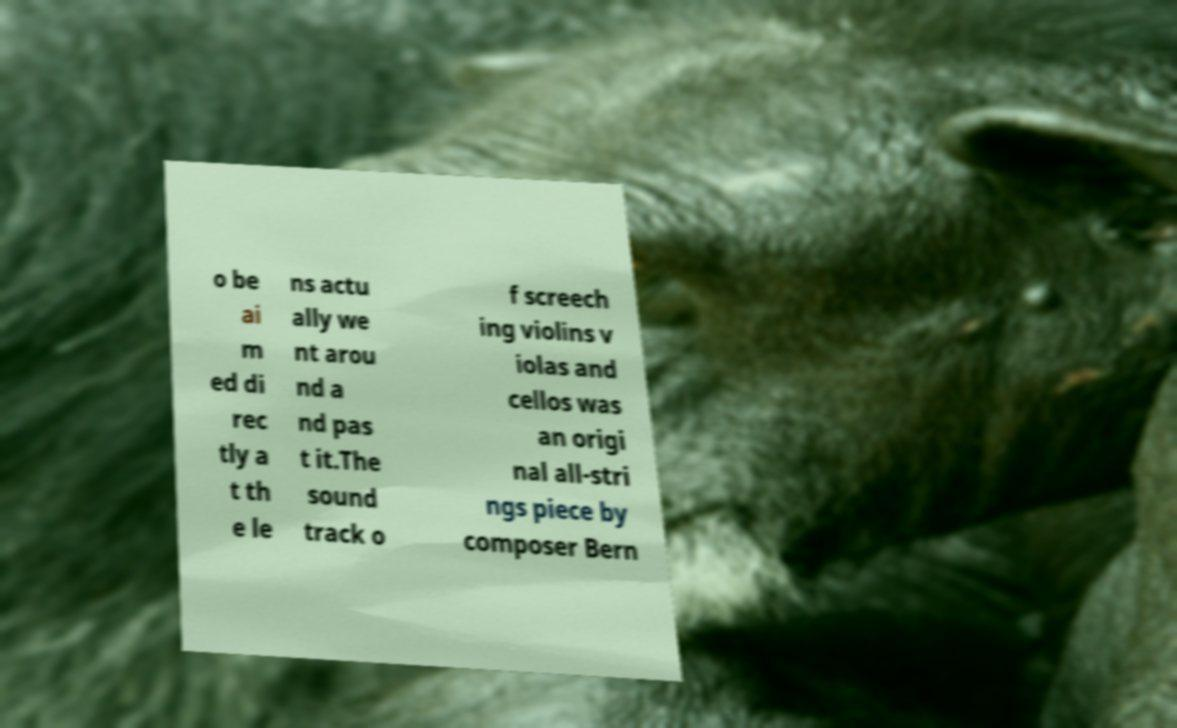Can you accurately transcribe the text from the provided image for me? o be ai m ed di rec tly a t th e le ns actu ally we nt arou nd a nd pas t it.The sound track o f screech ing violins v iolas and cellos was an origi nal all-stri ngs piece by composer Bern 